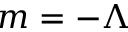Convert formula to latex. <formula><loc_0><loc_0><loc_500><loc_500>m = - \Lambda</formula> 